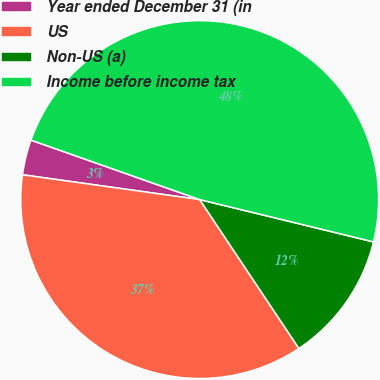Convert chart to OTSL. <chart><loc_0><loc_0><loc_500><loc_500><pie_chart><fcel>Year ended December 31 (in<fcel>US<fcel>Non-US (a)<fcel>Income before income tax<nl><fcel>3.18%<fcel>36.57%<fcel>11.84%<fcel>48.41%<nl></chart> 